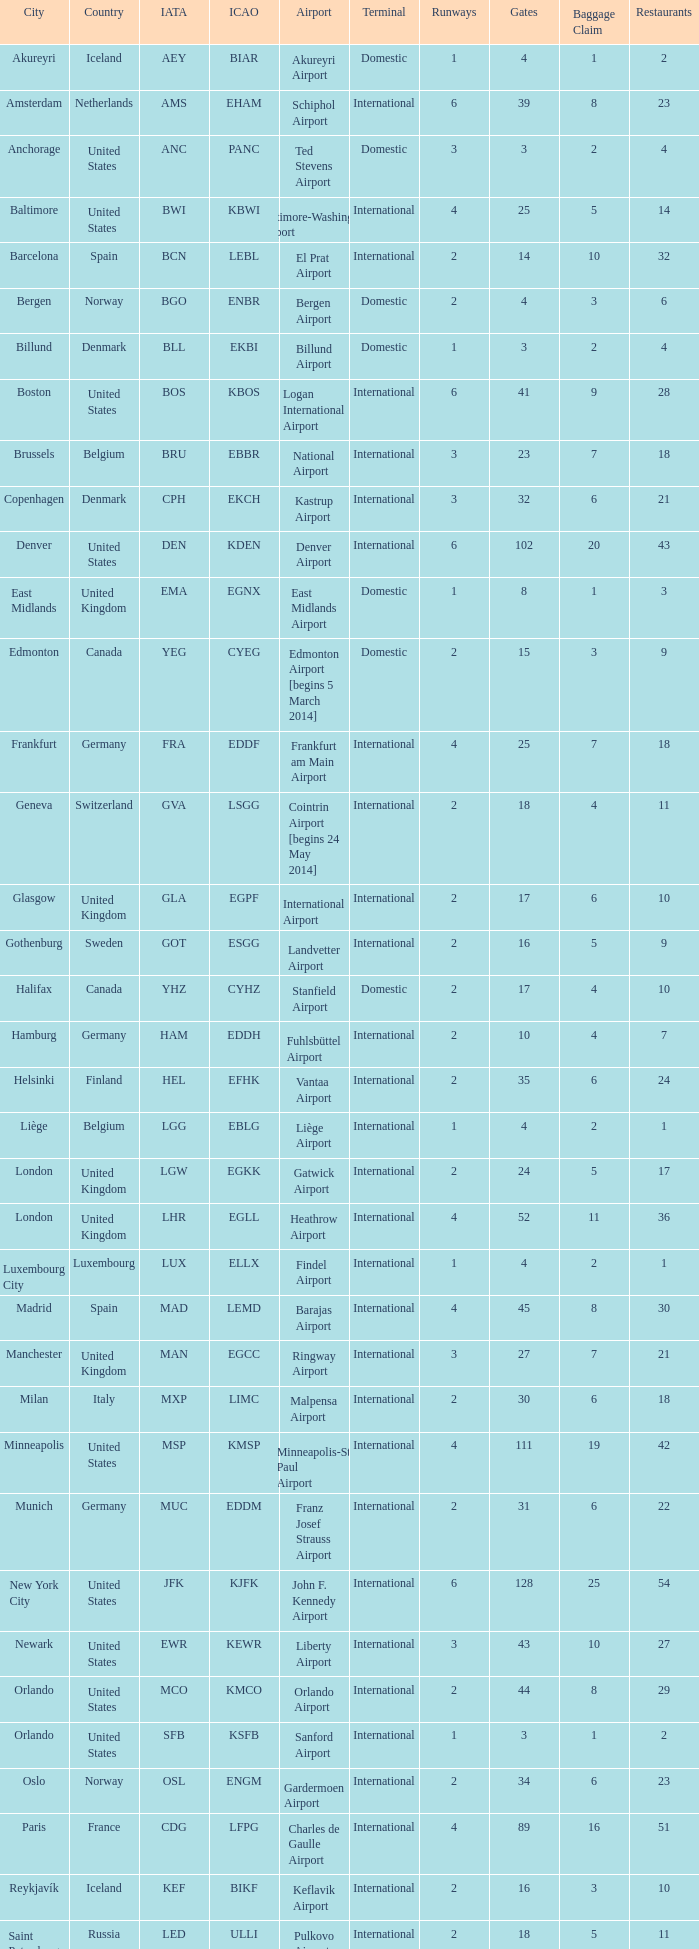What is the Airport with a ICAO of EDDH? Fuhlsbüttel Airport. 